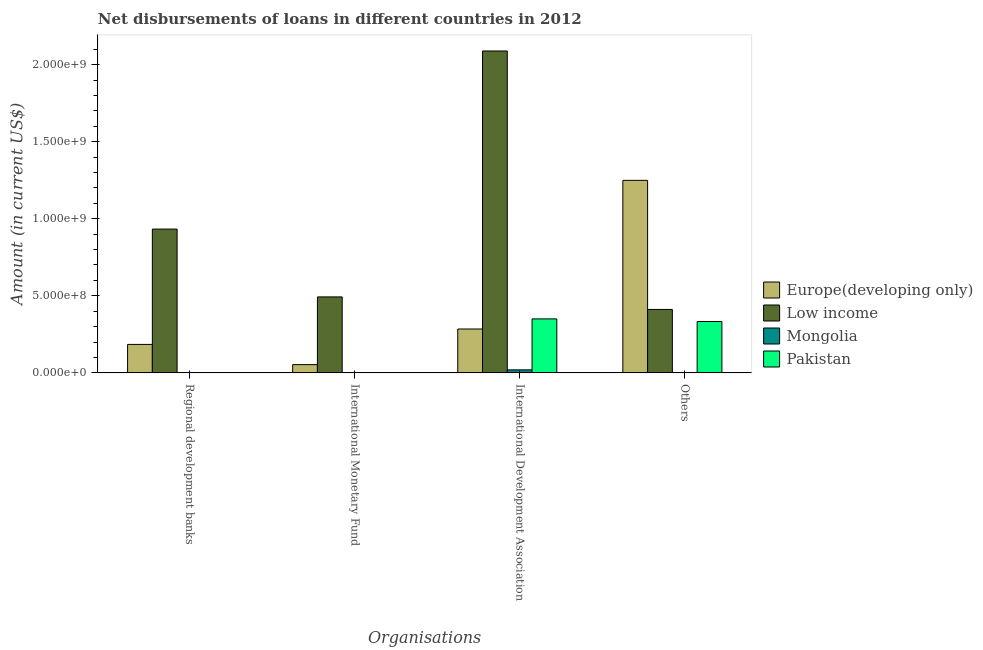How many different coloured bars are there?
Provide a short and direct response. 4. How many groups of bars are there?
Offer a terse response. 4. Are the number of bars per tick equal to the number of legend labels?
Your response must be concise. No. Are the number of bars on each tick of the X-axis equal?
Provide a short and direct response. No. How many bars are there on the 2nd tick from the right?
Give a very brief answer. 4. What is the label of the 4th group of bars from the left?
Ensure brevity in your answer.  Others. What is the amount of loan disimbursed by regional development banks in Europe(developing only)?
Your answer should be compact. 1.85e+08. Across all countries, what is the maximum amount of loan disimbursed by other organisations?
Make the answer very short. 1.25e+09. Across all countries, what is the minimum amount of loan disimbursed by international development association?
Ensure brevity in your answer.  1.95e+07. What is the total amount of loan disimbursed by other organisations in the graph?
Your response must be concise. 1.99e+09. What is the difference between the amount of loan disimbursed by other organisations in Europe(developing only) and that in Low income?
Offer a terse response. 8.37e+08. What is the difference between the amount of loan disimbursed by regional development banks in Low income and the amount of loan disimbursed by international monetary fund in Mongolia?
Keep it short and to the point. 9.33e+08. What is the average amount of loan disimbursed by international development association per country?
Ensure brevity in your answer.  6.86e+08. What is the difference between the amount of loan disimbursed by international development association and amount of loan disimbursed by other organisations in Mongolia?
Offer a terse response. 1.95e+07. In how many countries, is the amount of loan disimbursed by international development association greater than 400000000 US$?
Offer a very short reply. 1. What is the ratio of the amount of loan disimbursed by other organisations in Low income to that in Europe(developing only)?
Keep it short and to the point. 0.33. What is the difference between the highest and the second highest amount of loan disimbursed by international development association?
Keep it short and to the point. 1.74e+09. What is the difference between the highest and the lowest amount of loan disimbursed by other organisations?
Ensure brevity in your answer.  1.25e+09. In how many countries, is the amount of loan disimbursed by international monetary fund greater than the average amount of loan disimbursed by international monetary fund taken over all countries?
Provide a succinct answer. 1. Is it the case that in every country, the sum of the amount of loan disimbursed by international development association and amount of loan disimbursed by other organisations is greater than the sum of amount of loan disimbursed by regional development banks and amount of loan disimbursed by international monetary fund?
Keep it short and to the point. No. Are all the bars in the graph horizontal?
Your answer should be compact. No. What is the difference between two consecutive major ticks on the Y-axis?
Ensure brevity in your answer.  5.00e+08. Are the values on the major ticks of Y-axis written in scientific E-notation?
Give a very brief answer. Yes. Does the graph contain grids?
Your response must be concise. No. Where does the legend appear in the graph?
Your answer should be compact. Center right. How many legend labels are there?
Provide a short and direct response. 4. What is the title of the graph?
Offer a very short reply. Net disbursements of loans in different countries in 2012. What is the label or title of the X-axis?
Offer a very short reply. Organisations. What is the Amount (in current US$) in Europe(developing only) in Regional development banks?
Give a very brief answer. 1.85e+08. What is the Amount (in current US$) in Low income in Regional development banks?
Provide a short and direct response. 9.33e+08. What is the Amount (in current US$) in Mongolia in Regional development banks?
Offer a very short reply. 0. What is the Amount (in current US$) of Pakistan in Regional development banks?
Make the answer very short. 0. What is the Amount (in current US$) in Europe(developing only) in International Monetary Fund?
Offer a terse response. 5.35e+07. What is the Amount (in current US$) in Low income in International Monetary Fund?
Offer a terse response. 4.93e+08. What is the Amount (in current US$) in Mongolia in International Monetary Fund?
Make the answer very short. 0. What is the Amount (in current US$) in Europe(developing only) in International Development Association?
Keep it short and to the point. 2.85e+08. What is the Amount (in current US$) in Low income in International Development Association?
Make the answer very short. 2.09e+09. What is the Amount (in current US$) of Mongolia in International Development Association?
Offer a terse response. 1.95e+07. What is the Amount (in current US$) of Pakistan in International Development Association?
Your response must be concise. 3.50e+08. What is the Amount (in current US$) in Europe(developing only) in Others?
Provide a succinct answer. 1.25e+09. What is the Amount (in current US$) in Low income in Others?
Your response must be concise. 4.12e+08. What is the Amount (in current US$) of Mongolia in Others?
Ensure brevity in your answer.  2.90e+04. What is the Amount (in current US$) in Pakistan in Others?
Your response must be concise. 3.33e+08. Across all Organisations, what is the maximum Amount (in current US$) in Europe(developing only)?
Your response must be concise. 1.25e+09. Across all Organisations, what is the maximum Amount (in current US$) of Low income?
Offer a terse response. 2.09e+09. Across all Organisations, what is the maximum Amount (in current US$) of Mongolia?
Provide a succinct answer. 1.95e+07. Across all Organisations, what is the maximum Amount (in current US$) in Pakistan?
Your answer should be compact. 3.50e+08. Across all Organisations, what is the minimum Amount (in current US$) of Europe(developing only)?
Keep it short and to the point. 5.35e+07. Across all Organisations, what is the minimum Amount (in current US$) of Low income?
Ensure brevity in your answer.  4.12e+08. Across all Organisations, what is the minimum Amount (in current US$) of Mongolia?
Give a very brief answer. 0. What is the total Amount (in current US$) in Europe(developing only) in the graph?
Your answer should be compact. 1.77e+09. What is the total Amount (in current US$) of Low income in the graph?
Your answer should be very brief. 3.93e+09. What is the total Amount (in current US$) of Mongolia in the graph?
Your answer should be compact. 1.95e+07. What is the total Amount (in current US$) in Pakistan in the graph?
Make the answer very short. 6.84e+08. What is the difference between the Amount (in current US$) in Europe(developing only) in Regional development banks and that in International Monetary Fund?
Your answer should be compact. 1.31e+08. What is the difference between the Amount (in current US$) of Low income in Regional development banks and that in International Monetary Fund?
Keep it short and to the point. 4.40e+08. What is the difference between the Amount (in current US$) of Europe(developing only) in Regional development banks and that in International Development Association?
Provide a short and direct response. -1.00e+08. What is the difference between the Amount (in current US$) in Low income in Regional development banks and that in International Development Association?
Your answer should be very brief. -1.16e+09. What is the difference between the Amount (in current US$) of Europe(developing only) in Regional development banks and that in Others?
Keep it short and to the point. -1.06e+09. What is the difference between the Amount (in current US$) in Low income in Regional development banks and that in Others?
Keep it short and to the point. 5.21e+08. What is the difference between the Amount (in current US$) in Europe(developing only) in International Monetary Fund and that in International Development Association?
Keep it short and to the point. -2.31e+08. What is the difference between the Amount (in current US$) of Low income in International Monetary Fund and that in International Development Association?
Offer a terse response. -1.60e+09. What is the difference between the Amount (in current US$) in Europe(developing only) in International Monetary Fund and that in Others?
Offer a very short reply. -1.20e+09. What is the difference between the Amount (in current US$) of Low income in International Monetary Fund and that in Others?
Offer a very short reply. 8.12e+07. What is the difference between the Amount (in current US$) of Europe(developing only) in International Development Association and that in Others?
Give a very brief answer. -9.64e+08. What is the difference between the Amount (in current US$) in Low income in International Development Association and that in Others?
Your answer should be compact. 1.68e+09. What is the difference between the Amount (in current US$) in Mongolia in International Development Association and that in Others?
Your response must be concise. 1.95e+07. What is the difference between the Amount (in current US$) in Pakistan in International Development Association and that in Others?
Give a very brief answer. 1.68e+07. What is the difference between the Amount (in current US$) in Europe(developing only) in Regional development banks and the Amount (in current US$) in Low income in International Monetary Fund?
Provide a succinct answer. -3.08e+08. What is the difference between the Amount (in current US$) of Europe(developing only) in Regional development banks and the Amount (in current US$) of Low income in International Development Association?
Offer a very short reply. -1.90e+09. What is the difference between the Amount (in current US$) of Europe(developing only) in Regional development banks and the Amount (in current US$) of Mongolia in International Development Association?
Ensure brevity in your answer.  1.65e+08. What is the difference between the Amount (in current US$) of Europe(developing only) in Regional development banks and the Amount (in current US$) of Pakistan in International Development Association?
Make the answer very short. -1.66e+08. What is the difference between the Amount (in current US$) of Low income in Regional development banks and the Amount (in current US$) of Mongolia in International Development Association?
Ensure brevity in your answer.  9.13e+08. What is the difference between the Amount (in current US$) in Low income in Regional development banks and the Amount (in current US$) in Pakistan in International Development Association?
Ensure brevity in your answer.  5.83e+08. What is the difference between the Amount (in current US$) of Europe(developing only) in Regional development banks and the Amount (in current US$) of Low income in Others?
Give a very brief answer. -2.27e+08. What is the difference between the Amount (in current US$) of Europe(developing only) in Regional development banks and the Amount (in current US$) of Mongolia in Others?
Offer a very short reply. 1.85e+08. What is the difference between the Amount (in current US$) of Europe(developing only) in Regional development banks and the Amount (in current US$) of Pakistan in Others?
Make the answer very short. -1.49e+08. What is the difference between the Amount (in current US$) in Low income in Regional development banks and the Amount (in current US$) in Mongolia in Others?
Ensure brevity in your answer.  9.33e+08. What is the difference between the Amount (in current US$) in Low income in Regional development banks and the Amount (in current US$) in Pakistan in Others?
Your answer should be compact. 6.00e+08. What is the difference between the Amount (in current US$) of Europe(developing only) in International Monetary Fund and the Amount (in current US$) of Low income in International Development Association?
Your answer should be very brief. -2.04e+09. What is the difference between the Amount (in current US$) in Europe(developing only) in International Monetary Fund and the Amount (in current US$) in Mongolia in International Development Association?
Your answer should be very brief. 3.40e+07. What is the difference between the Amount (in current US$) of Europe(developing only) in International Monetary Fund and the Amount (in current US$) of Pakistan in International Development Association?
Offer a very short reply. -2.97e+08. What is the difference between the Amount (in current US$) of Low income in International Monetary Fund and the Amount (in current US$) of Mongolia in International Development Association?
Provide a succinct answer. 4.73e+08. What is the difference between the Amount (in current US$) of Low income in International Monetary Fund and the Amount (in current US$) of Pakistan in International Development Association?
Offer a terse response. 1.43e+08. What is the difference between the Amount (in current US$) of Europe(developing only) in International Monetary Fund and the Amount (in current US$) of Low income in Others?
Offer a very short reply. -3.58e+08. What is the difference between the Amount (in current US$) of Europe(developing only) in International Monetary Fund and the Amount (in current US$) of Mongolia in Others?
Ensure brevity in your answer.  5.34e+07. What is the difference between the Amount (in current US$) of Europe(developing only) in International Monetary Fund and the Amount (in current US$) of Pakistan in Others?
Make the answer very short. -2.80e+08. What is the difference between the Amount (in current US$) in Low income in International Monetary Fund and the Amount (in current US$) in Mongolia in Others?
Offer a very short reply. 4.93e+08. What is the difference between the Amount (in current US$) of Low income in International Monetary Fund and the Amount (in current US$) of Pakistan in Others?
Your response must be concise. 1.59e+08. What is the difference between the Amount (in current US$) in Europe(developing only) in International Development Association and the Amount (in current US$) in Low income in Others?
Ensure brevity in your answer.  -1.27e+08. What is the difference between the Amount (in current US$) of Europe(developing only) in International Development Association and the Amount (in current US$) of Mongolia in Others?
Offer a very short reply. 2.85e+08. What is the difference between the Amount (in current US$) of Europe(developing only) in International Development Association and the Amount (in current US$) of Pakistan in Others?
Your response must be concise. -4.87e+07. What is the difference between the Amount (in current US$) of Low income in International Development Association and the Amount (in current US$) of Mongolia in Others?
Make the answer very short. 2.09e+09. What is the difference between the Amount (in current US$) in Low income in International Development Association and the Amount (in current US$) in Pakistan in Others?
Your response must be concise. 1.76e+09. What is the difference between the Amount (in current US$) of Mongolia in International Development Association and the Amount (in current US$) of Pakistan in Others?
Your response must be concise. -3.14e+08. What is the average Amount (in current US$) of Europe(developing only) per Organisations?
Give a very brief answer. 4.43e+08. What is the average Amount (in current US$) in Low income per Organisations?
Provide a short and direct response. 9.82e+08. What is the average Amount (in current US$) in Mongolia per Organisations?
Keep it short and to the point. 4.88e+06. What is the average Amount (in current US$) of Pakistan per Organisations?
Provide a short and direct response. 1.71e+08. What is the difference between the Amount (in current US$) of Europe(developing only) and Amount (in current US$) of Low income in Regional development banks?
Make the answer very short. -7.48e+08. What is the difference between the Amount (in current US$) of Europe(developing only) and Amount (in current US$) of Low income in International Monetary Fund?
Your answer should be compact. -4.39e+08. What is the difference between the Amount (in current US$) of Europe(developing only) and Amount (in current US$) of Low income in International Development Association?
Your answer should be compact. -1.80e+09. What is the difference between the Amount (in current US$) in Europe(developing only) and Amount (in current US$) in Mongolia in International Development Association?
Give a very brief answer. 2.65e+08. What is the difference between the Amount (in current US$) of Europe(developing only) and Amount (in current US$) of Pakistan in International Development Association?
Give a very brief answer. -6.55e+07. What is the difference between the Amount (in current US$) in Low income and Amount (in current US$) in Mongolia in International Development Association?
Ensure brevity in your answer.  2.07e+09. What is the difference between the Amount (in current US$) in Low income and Amount (in current US$) in Pakistan in International Development Association?
Provide a succinct answer. 1.74e+09. What is the difference between the Amount (in current US$) of Mongolia and Amount (in current US$) of Pakistan in International Development Association?
Make the answer very short. -3.31e+08. What is the difference between the Amount (in current US$) of Europe(developing only) and Amount (in current US$) of Low income in Others?
Your response must be concise. 8.37e+08. What is the difference between the Amount (in current US$) of Europe(developing only) and Amount (in current US$) of Mongolia in Others?
Give a very brief answer. 1.25e+09. What is the difference between the Amount (in current US$) of Europe(developing only) and Amount (in current US$) of Pakistan in Others?
Offer a very short reply. 9.16e+08. What is the difference between the Amount (in current US$) in Low income and Amount (in current US$) in Mongolia in Others?
Provide a short and direct response. 4.12e+08. What is the difference between the Amount (in current US$) in Low income and Amount (in current US$) in Pakistan in Others?
Your response must be concise. 7.83e+07. What is the difference between the Amount (in current US$) of Mongolia and Amount (in current US$) of Pakistan in Others?
Make the answer very short. -3.33e+08. What is the ratio of the Amount (in current US$) of Europe(developing only) in Regional development banks to that in International Monetary Fund?
Ensure brevity in your answer.  3.45. What is the ratio of the Amount (in current US$) of Low income in Regional development banks to that in International Monetary Fund?
Your answer should be compact. 1.89. What is the ratio of the Amount (in current US$) of Europe(developing only) in Regional development banks to that in International Development Association?
Offer a terse response. 0.65. What is the ratio of the Amount (in current US$) of Low income in Regional development banks to that in International Development Association?
Ensure brevity in your answer.  0.45. What is the ratio of the Amount (in current US$) of Europe(developing only) in Regional development banks to that in Others?
Your response must be concise. 0.15. What is the ratio of the Amount (in current US$) in Low income in Regional development banks to that in Others?
Give a very brief answer. 2.27. What is the ratio of the Amount (in current US$) of Europe(developing only) in International Monetary Fund to that in International Development Association?
Ensure brevity in your answer.  0.19. What is the ratio of the Amount (in current US$) of Low income in International Monetary Fund to that in International Development Association?
Make the answer very short. 0.24. What is the ratio of the Amount (in current US$) of Europe(developing only) in International Monetary Fund to that in Others?
Provide a short and direct response. 0.04. What is the ratio of the Amount (in current US$) in Low income in International Monetary Fund to that in Others?
Keep it short and to the point. 1.2. What is the ratio of the Amount (in current US$) in Europe(developing only) in International Development Association to that in Others?
Make the answer very short. 0.23. What is the ratio of the Amount (in current US$) of Low income in International Development Association to that in Others?
Offer a very short reply. 5.07. What is the ratio of the Amount (in current US$) of Mongolia in International Development Association to that in Others?
Provide a succinct answer. 672.79. What is the ratio of the Amount (in current US$) of Pakistan in International Development Association to that in Others?
Your answer should be very brief. 1.05. What is the difference between the highest and the second highest Amount (in current US$) in Europe(developing only)?
Give a very brief answer. 9.64e+08. What is the difference between the highest and the second highest Amount (in current US$) of Low income?
Offer a very short reply. 1.16e+09. What is the difference between the highest and the lowest Amount (in current US$) in Europe(developing only)?
Offer a very short reply. 1.20e+09. What is the difference between the highest and the lowest Amount (in current US$) in Low income?
Your answer should be compact. 1.68e+09. What is the difference between the highest and the lowest Amount (in current US$) in Mongolia?
Your response must be concise. 1.95e+07. What is the difference between the highest and the lowest Amount (in current US$) in Pakistan?
Your response must be concise. 3.50e+08. 